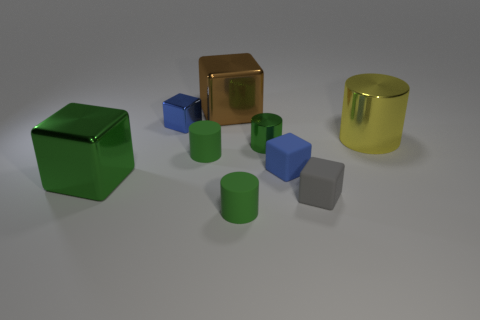Subtract all green cubes. How many green cylinders are left? 3 Subtract 1 cylinders. How many cylinders are left? 3 Subtract all green cubes. How many cubes are left? 4 Subtract all brown metal cubes. How many cubes are left? 4 Subtract all gray blocks. Subtract all brown spheres. How many blocks are left? 4 Add 1 brown shiny balls. How many objects exist? 10 Subtract all blocks. How many objects are left? 4 Subtract all large green metal objects. Subtract all tiny green metallic spheres. How many objects are left? 8 Add 7 tiny green metal cylinders. How many tiny green metal cylinders are left? 8 Add 1 yellow things. How many yellow things exist? 2 